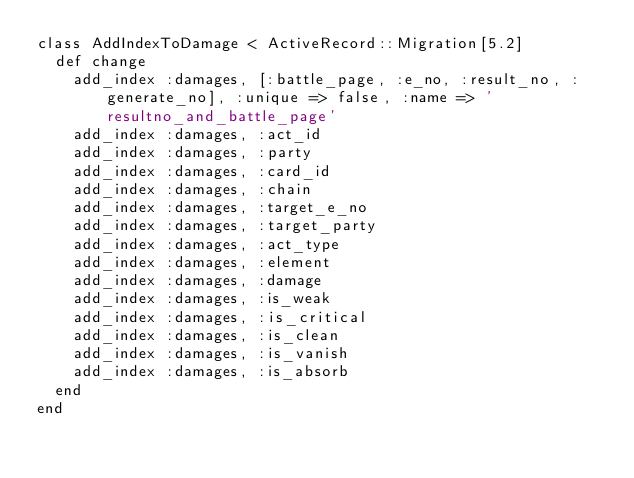<code> <loc_0><loc_0><loc_500><loc_500><_Ruby_>class AddIndexToDamage < ActiveRecord::Migration[5.2]
  def change
    add_index :damages, [:battle_page, :e_no, :result_no, :generate_no], :unique => false, :name => 'resultno_and_battle_page'
    add_index :damages, :act_id
    add_index :damages, :party
    add_index :damages, :card_id
    add_index :damages, :chain
    add_index :damages, :target_e_no
    add_index :damages, :target_party
    add_index :damages, :act_type
    add_index :damages, :element
    add_index :damages, :damage
    add_index :damages, :is_weak
    add_index :damages, :is_critical
    add_index :damages, :is_clean
    add_index :damages, :is_vanish
    add_index :damages, :is_absorb
  end
end
</code> 